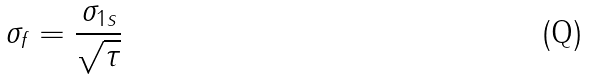<formula> <loc_0><loc_0><loc_500><loc_500>\sigma _ { f } = \frac { \sigma _ { 1 s } } { \sqrt { \tau } }</formula> 